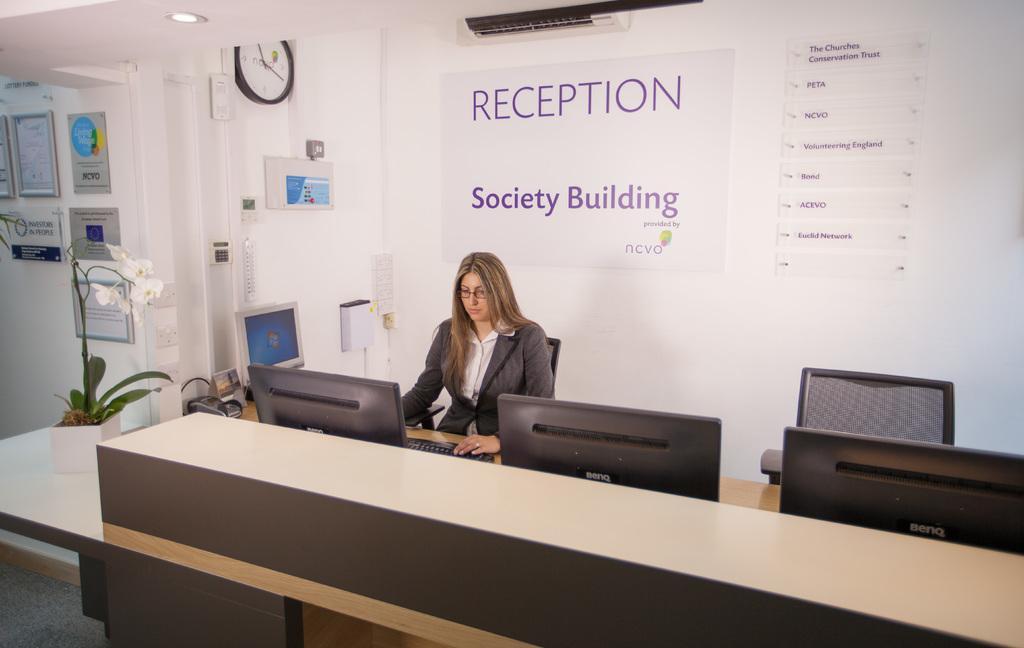Please provide a concise description of this image. In this picture we can see women wore blazer, spectacle sitting on chair and in front of her we have monitor, key board and at back of her we can see banner, wall, clock, flower pot with plant in it, frames. 